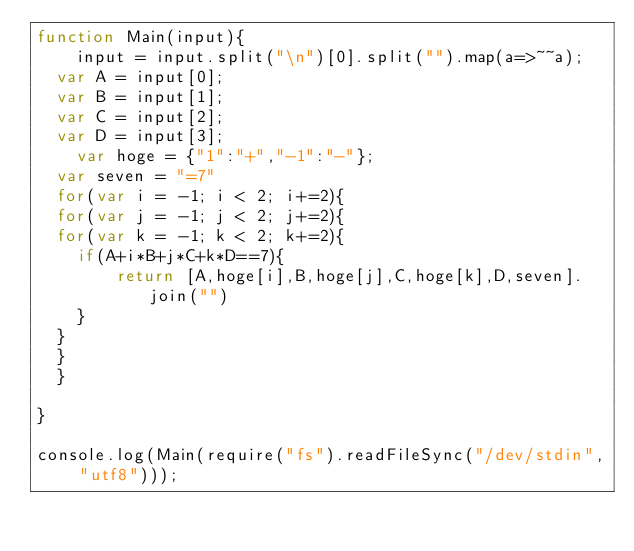Convert code to text. <code><loc_0><loc_0><loc_500><loc_500><_JavaScript_>function Main(input){
	input = input.split("\n")[0].split("").map(a=>~~a);
  var A = input[0];
  var B = input[1];
  var C = input[2];
  var D = input[3];
 	var hoge = {"1":"+","-1":"-"};
  var seven = "=7"
  for(var i = -1; i < 2; i+=2){
  for(var j = -1; j < 2; j+=2){
  for(var k = -1; k < 2; k+=2){
  	if(A+i*B+j*C+k*D==7){
    	return [A,hoge[i],B,hoge[j],C,hoge[k],D,seven].join("")
    }
  }
  }
  }
  
}

console.log(Main(require("fs").readFileSync("/dev/stdin", "utf8")));</code> 